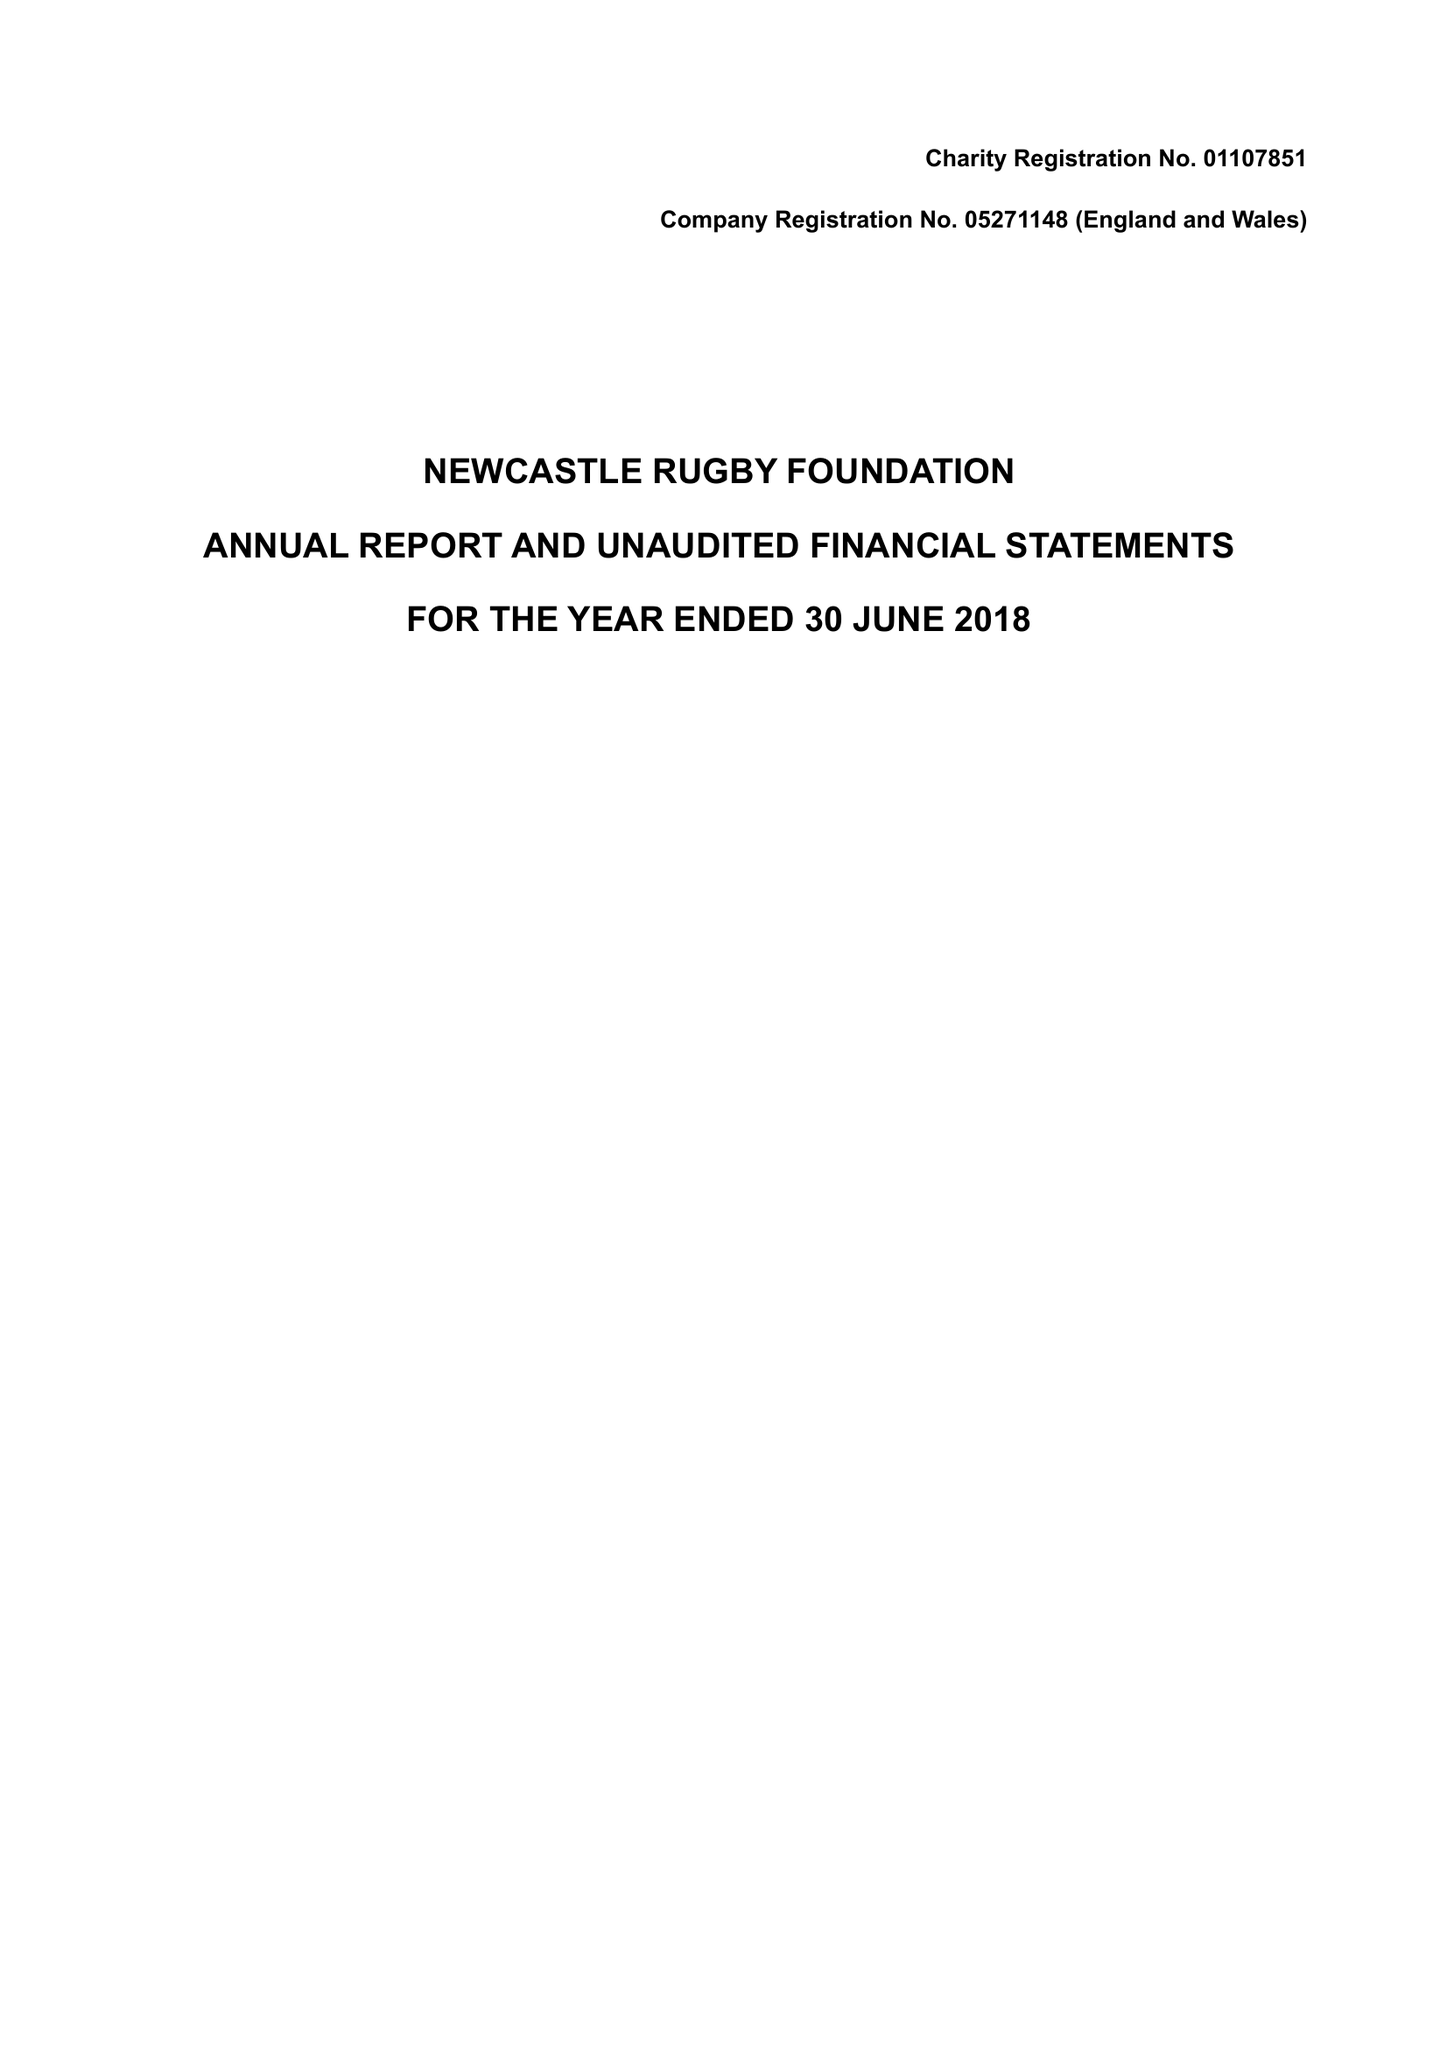What is the value for the address__street_line?
Answer the question using a single word or phrase. BRUNTON ROAD 